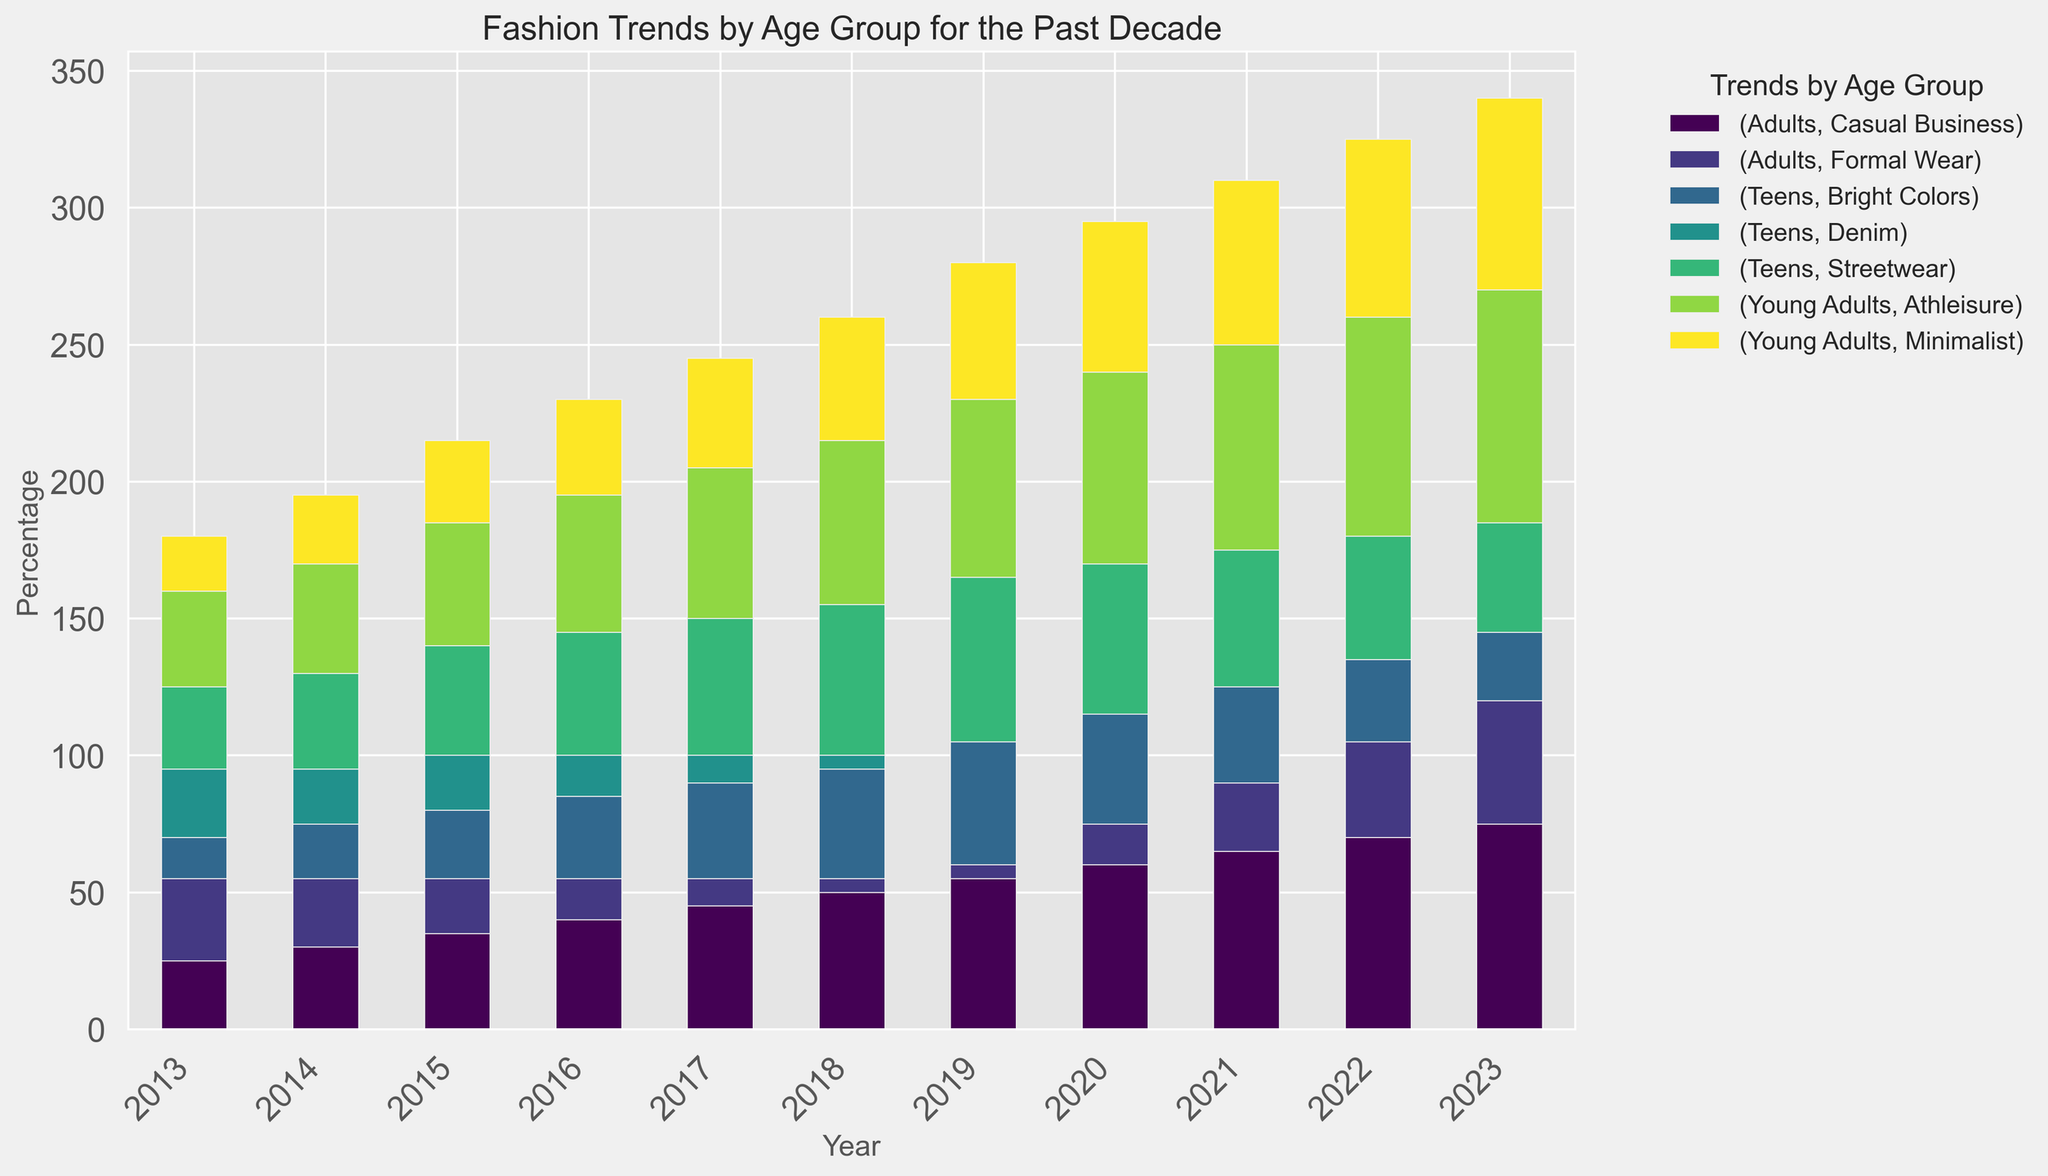Which trend was most popular among teens in 2018? In the bar chart for 2018, the highest bar for teens represents Streetwear.
Answer: Streetwear How has the popularity of Athleisure among young adults changed from 2013 to 2023? Check the height of the bars representing Athleisure for young adults in 2013 and 2023. In 2013, Athleisure has a lower percentage, while in 2023, the bar is significantly higher.
Answer: Increased What was the percentage difference in Casual Business wear for adults between 2015 and 2023? Check the bar heights for Casual Business wear for adults in 2015 and 2023. In 2015, it's 35%, and in 2023, it's 75%. The difference is 75% - 35% = 40%.
Answer: 40% Which age group saw the largest increase in trend percentage for Minimalist wear from 2014 to 2022? Compare the bar heights for Minimalist wear from 2014 to 2022 for each age group. Young adults increase significantly from 25% to 65%, which is a 40% increase.
Answer: Young adults In what year did Streetwear peak in popularity among teens? Look for the year with the highest bar for Streetwear under the teens category. The peak is in 2019 with 60%.
Answer: 2019 What's the combined percentage of Formal Wear and Casual Business among adults in 2021? Look at the bars for Formal Wear (25%) and Casual Business (65%) for adults in 2021. The sum is 25% + 65% = 90%.
Answer: 90% Did Minimalist trend ever exceed 50% among young adults from 2013 to 2023? Check the bars representing Minimalist for young adults from 2013 to 2023. The percentage exceeds 50% starting in 2020.
Answer: Yes Among teens, which year saw the sharpest decline in the popularity of Denim? To find the sharpest decline, compare the percentage of Denim for consecutive years. From 2017 to 2018, Denim decreased from 10% to 5%, marking the sharpest decline.
Answer: 2018 What is the trend percentage difference between Streetwear and Bright Colors among teens in 2020? In 2020, the percentage for Streetwear is 55%, and for Bright Colors, it is 40%. The difference is 55% - 40% = 15%.
Answer: 15% Which trend had the most consistent increase among young adults from 2013 to 2023? Check the bars' heights for each trend from 2013 to 2023 among young adults. Athleisure shows a consistent increase over the years.
Answer: Athleisure 